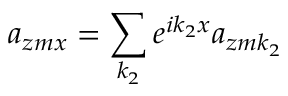Convert formula to latex. <formula><loc_0><loc_0><loc_500><loc_500>a _ { z m x } = \sum _ { k _ { 2 } } e ^ { i k _ { 2 } x } a _ { z m k _ { 2 } }</formula> 